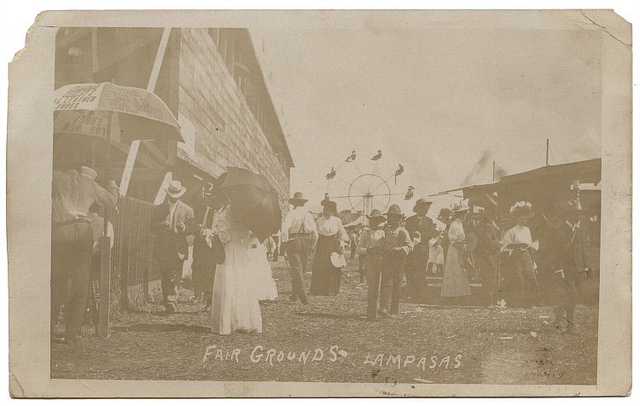Identify the text displayed in this image. FAIR GROUNDS LAMPASA 